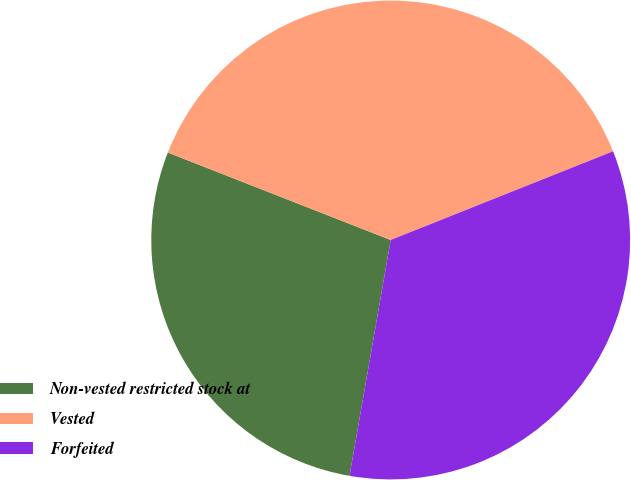Convert chart. <chart><loc_0><loc_0><loc_500><loc_500><pie_chart><fcel>Non-vested restricted stock at<fcel>Vested<fcel>Forfeited<nl><fcel>28.2%<fcel>38.01%<fcel>33.79%<nl></chart> 